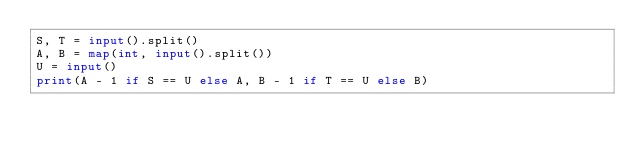<code> <loc_0><loc_0><loc_500><loc_500><_Python_>S, T = input().split()
A, B = map(int, input().split())
U = input()
print(A - 1 if S == U else A, B - 1 if T == U else B)</code> 